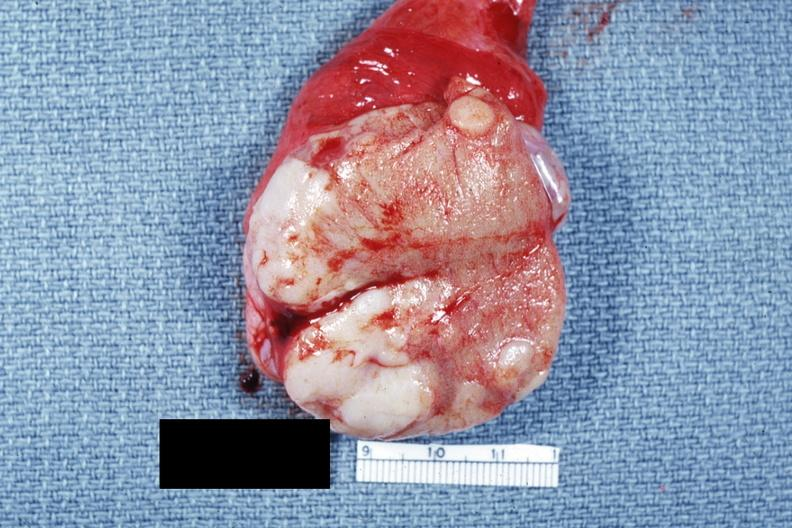s metastatic carcinoma present?
Answer the question using a single word or phrase. Yes 